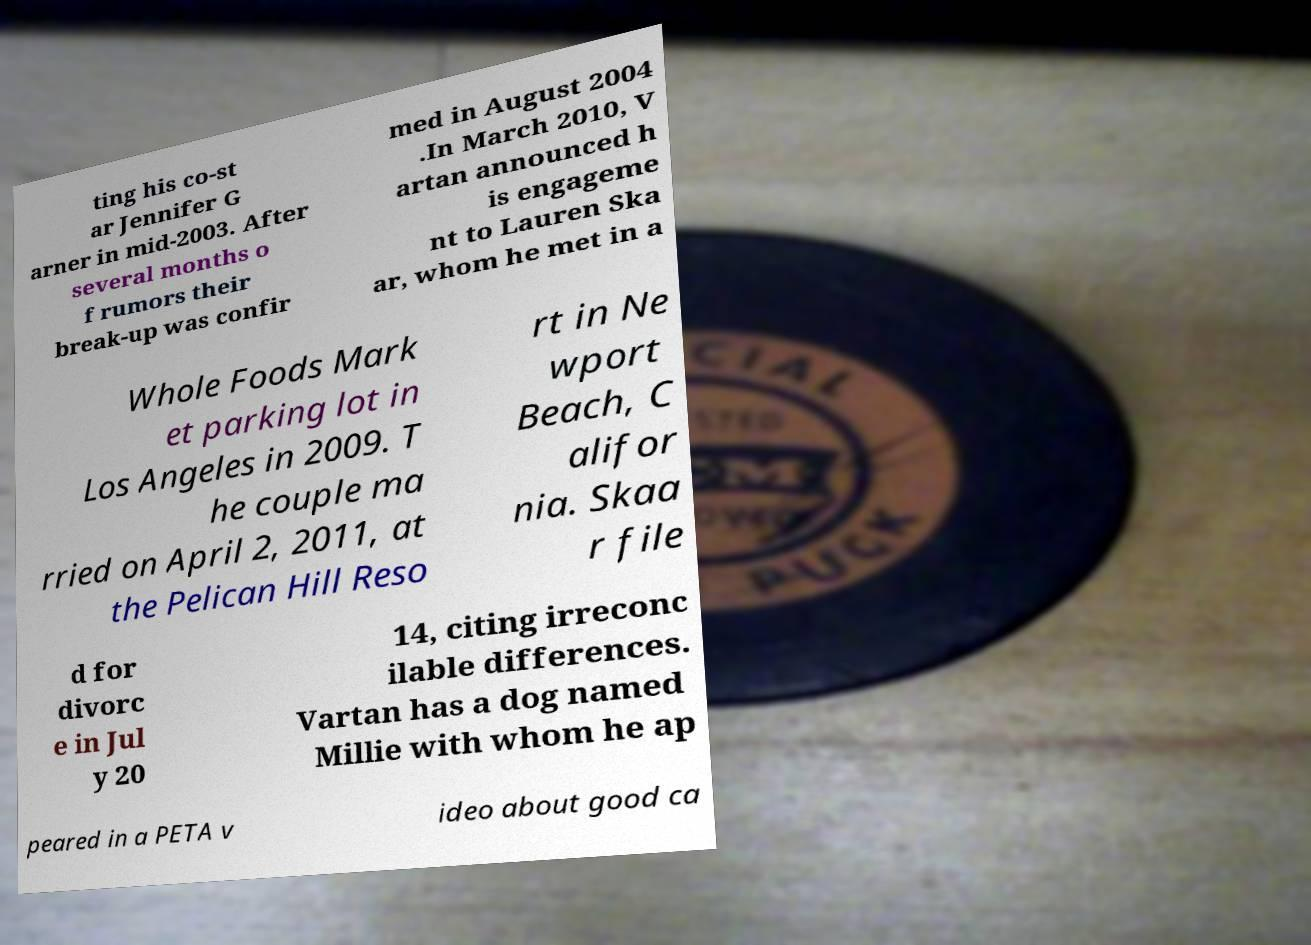What messages or text are displayed in this image? I need them in a readable, typed format. ting his co-st ar Jennifer G arner in mid-2003. After several months o f rumors their break-up was confir med in August 2004 .In March 2010, V artan announced h is engageme nt to Lauren Ska ar, whom he met in a Whole Foods Mark et parking lot in Los Angeles in 2009. T he couple ma rried on April 2, 2011, at the Pelican Hill Reso rt in Ne wport Beach, C alifor nia. Skaa r file d for divorc e in Jul y 20 14, citing irreconc ilable differences. Vartan has a dog named Millie with whom he ap peared in a PETA v ideo about good ca 